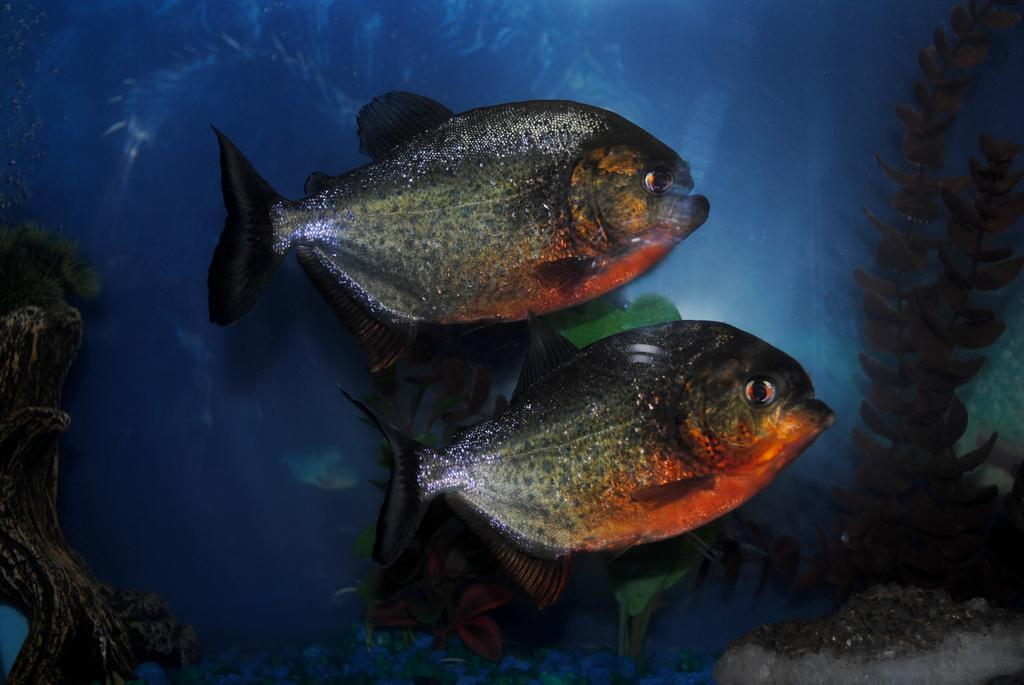What type of animals can be seen in the image? There are fishes in the image. What other elements are present in the image besides the fishes? There are plants and coral rocks in the image. What color is the background of the image? The background of the image is blue. What type of example is the lawyer providing in the image? There is no lawyer or example present in the image; it features fishes, plants, and coral rocks in a blue background. 